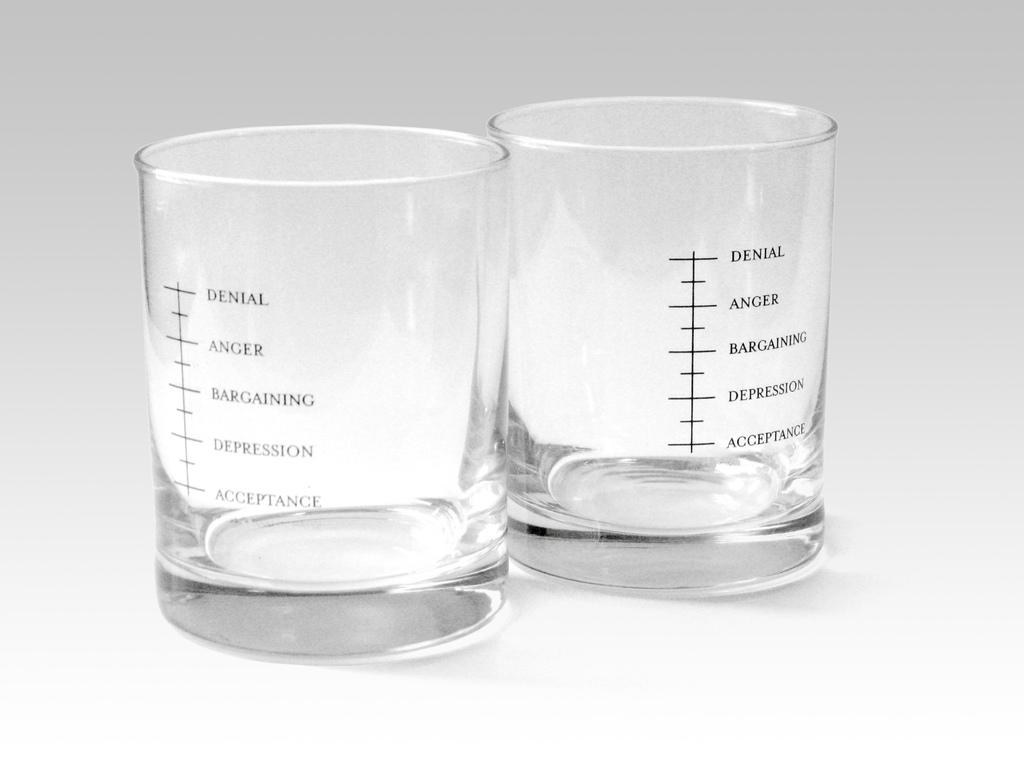<image>
Share a concise interpretation of the image provided. Shot glasses marked with stages of grief with denial at the top. 